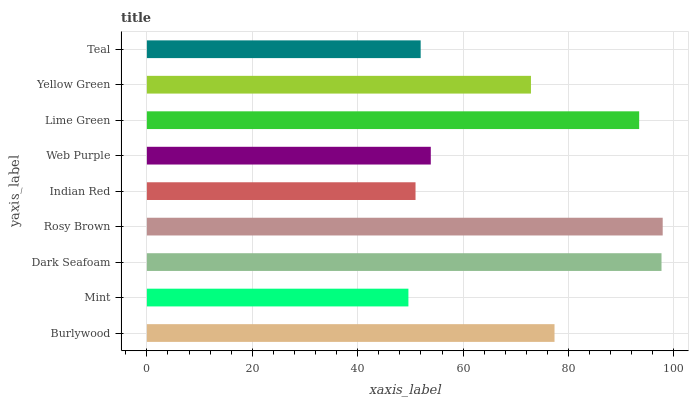Is Mint the minimum?
Answer yes or no. Yes. Is Rosy Brown the maximum?
Answer yes or no. Yes. Is Dark Seafoam the minimum?
Answer yes or no. No. Is Dark Seafoam the maximum?
Answer yes or no. No. Is Dark Seafoam greater than Mint?
Answer yes or no. Yes. Is Mint less than Dark Seafoam?
Answer yes or no. Yes. Is Mint greater than Dark Seafoam?
Answer yes or no. No. Is Dark Seafoam less than Mint?
Answer yes or no. No. Is Yellow Green the high median?
Answer yes or no. Yes. Is Yellow Green the low median?
Answer yes or no. Yes. Is Teal the high median?
Answer yes or no. No. Is Web Purple the low median?
Answer yes or no. No. 